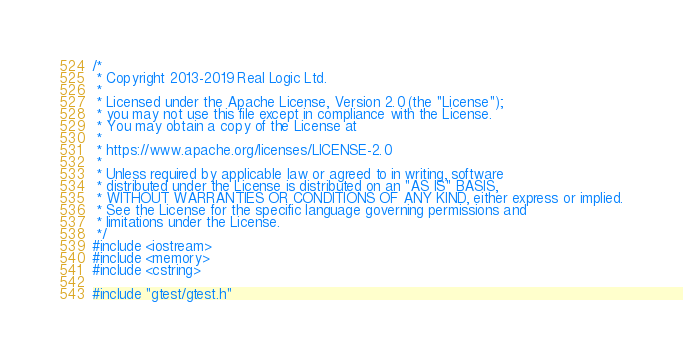Convert code to text. <code><loc_0><loc_0><loc_500><loc_500><_C++_>/*
 * Copyright 2013-2019 Real Logic Ltd.
 *
 * Licensed under the Apache License, Version 2.0 (the "License");
 * you may not use this file except in compliance with the License.
 * You may obtain a copy of the License at
 *
 * https://www.apache.org/licenses/LICENSE-2.0
 *
 * Unless required by applicable law or agreed to in writing, software
 * distributed under the License is distributed on an "AS IS" BASIS,
 * WITHOUT WARRANTIES OR CONDITIONS OF ANY KIND, either express or implied.
 * See the License for the specific language governing permissions and
 * limitations under the License.
 */
#include <iostream>
#include <memory>
#include <cstring>

#include "gtest/gtest.h"</code> 